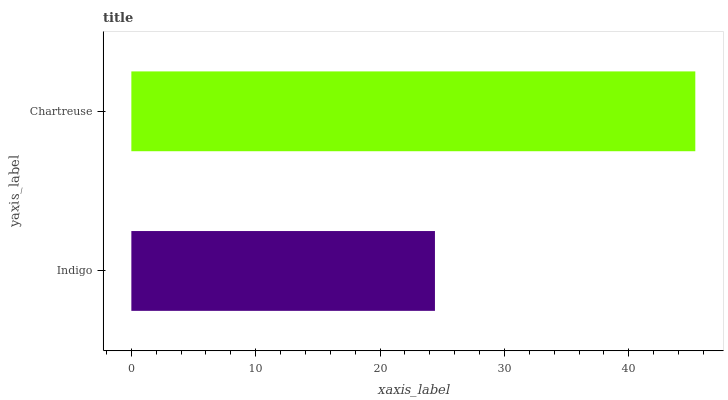Is Indigo the minimum?
Answer yes or no. Yes. Is Chartreuse the maximum?
Answer yes or no. Yes. Is Chartreuse the minimum?
Answer yes or no. No. Is Chartreuse greater than Indigo?
Answer yes or no. Yes. Is Indigo less than Chartreuse?
Answer yes or no. Yes. Is Indigo greater than Chartreuse?
Answer yes or no. No. Is Chartreuse less than Indigo?
Answer yes or no. No. Is Chartreuse the high median?
Answer yes or no. Yes. Is Indigo the low median?
Answer yes or no. Yes. Is Indigo the high median?
Answer yes or no. No. Is Chartreuse the low median?
Answer yes or no. No. 